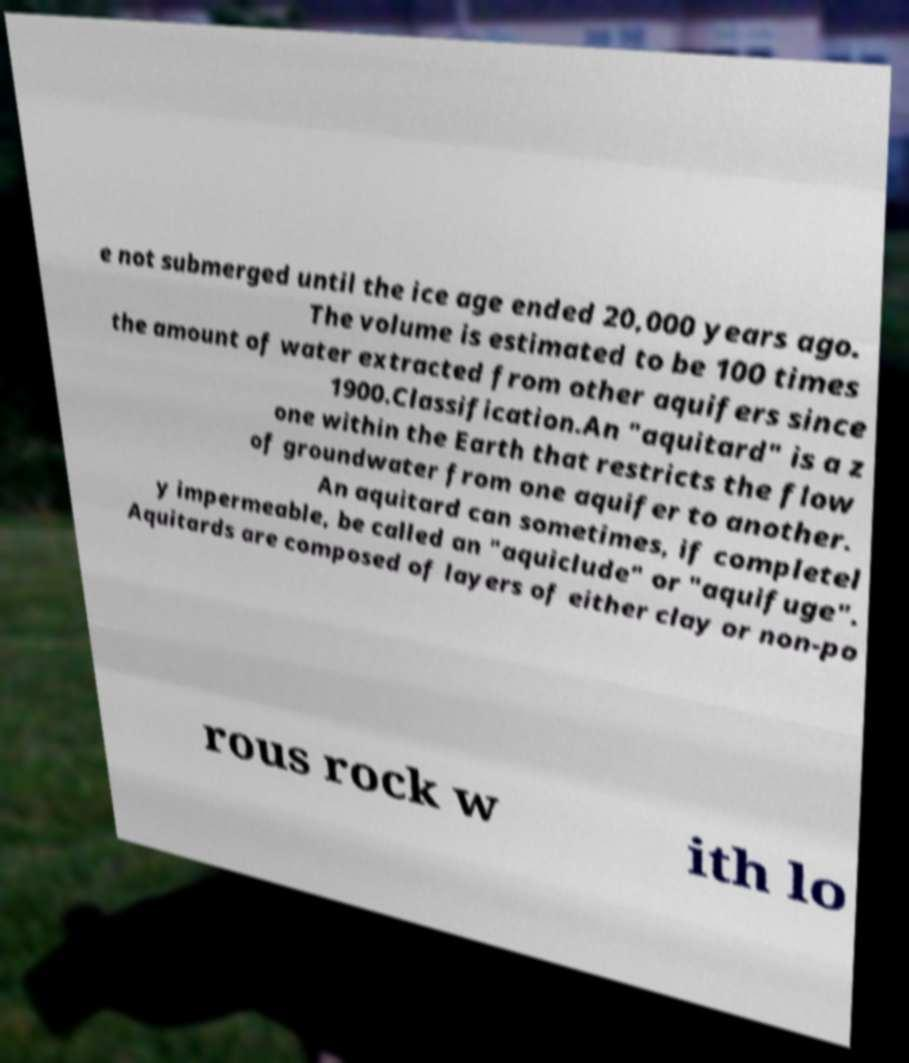What messages or text are displayed in this image? I need them in a readable, typed format. e not submerged until the ice age ended 20,000 years ago. The volume is estimated to be 100 times the amount of water extracted from other aquifers since 1900.Classification.An "aquitard" is a z one within the Earth that restricts the flow of groundwater from one aquifer to another. An aquitard can sometimes, if completel y impermeable, be called an "aquiclude" or "aquifuge". Aquitards are composed of layers of either clay or non-po rous rock w ith lo 